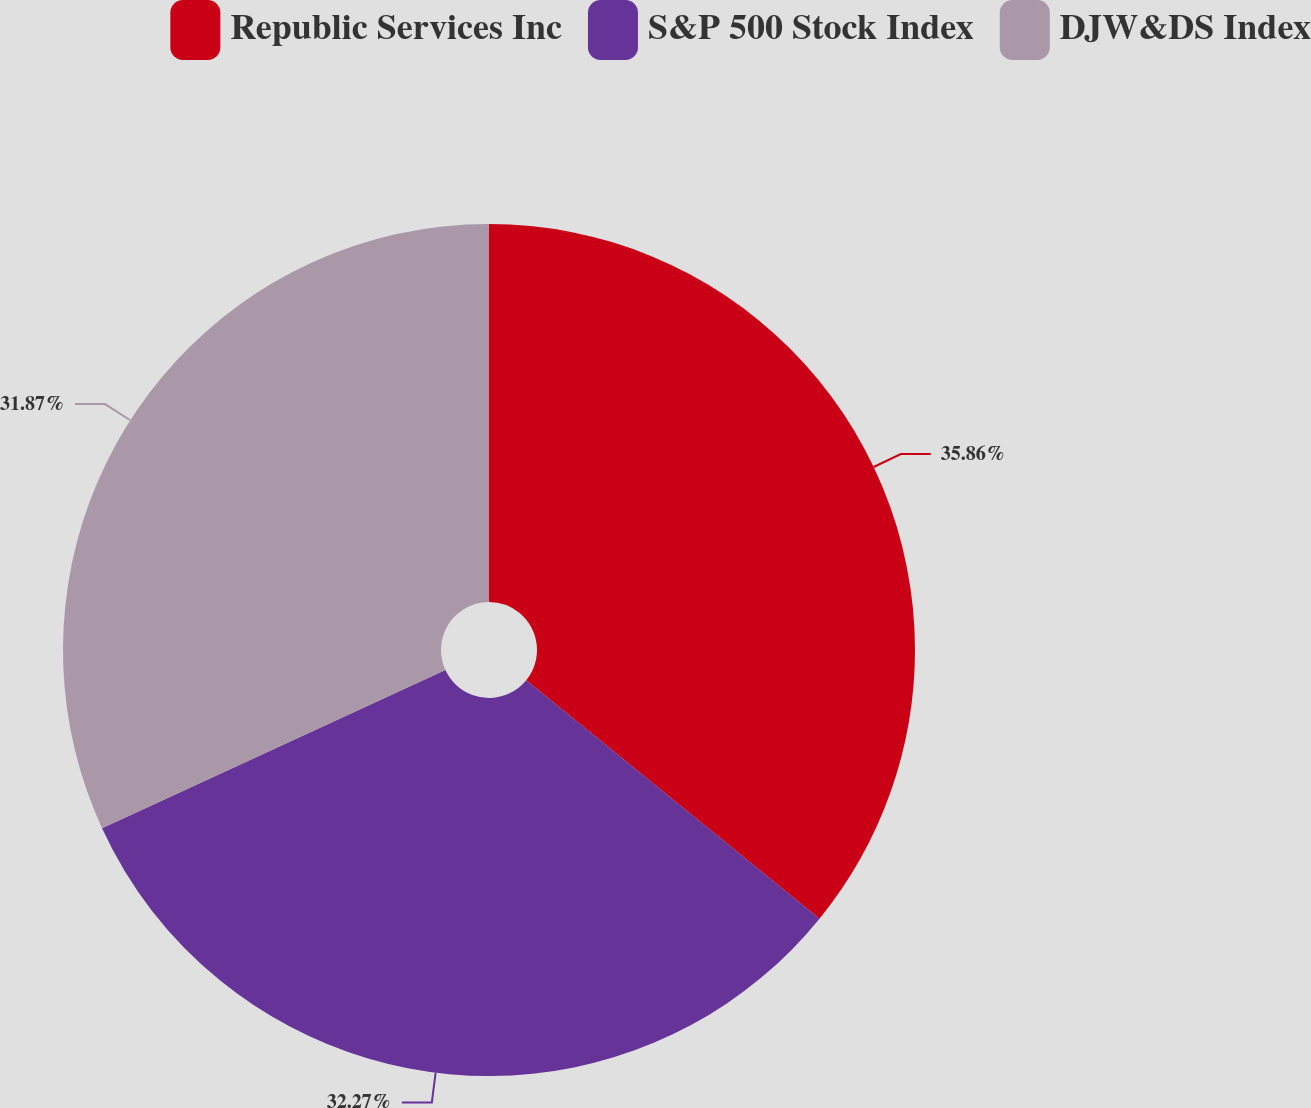Convert chart to OTSL. <chart><loc_0><loc_0><loc_500><loc_500><pie_chart><fcel>Republic Services Inc<fcel>S&P 500 Stock Index<fcel>DJW&DS Index<nl><fcel>35.87%<fcel>32.27%<fcel>31.87%<nl></chart> 